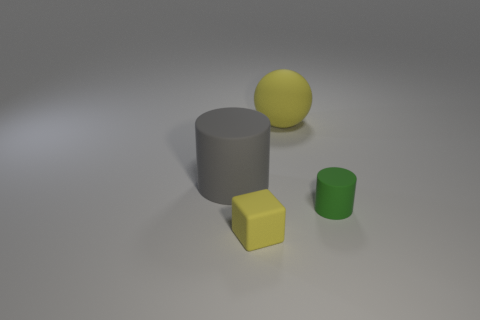Could you describe how lighting and shadows contribute to the perception of these objects? The image employs soft lighting and subtle shadows to give depth and dimension to the objects. The soft shadows cast on the ground help us understand the spatial relationships between the objects. They indicate the light source's direction, suggest the time of day it might represent if it were natural lighting, and enhance the realism of the scene by providing a sense of texture and weight to the objects. Does the shadow direction help in determining the shape of objects? Yes, shadows are quite informative. For example, the elongated shadow of the cylinder indicates its height and circular base, while the distinct edges of the cube's shadow perfectly outline its square faces. Each shadow conforms to the shape of the object that casts it, offering clues about its form even if the object itself wasn't clearly visible. 